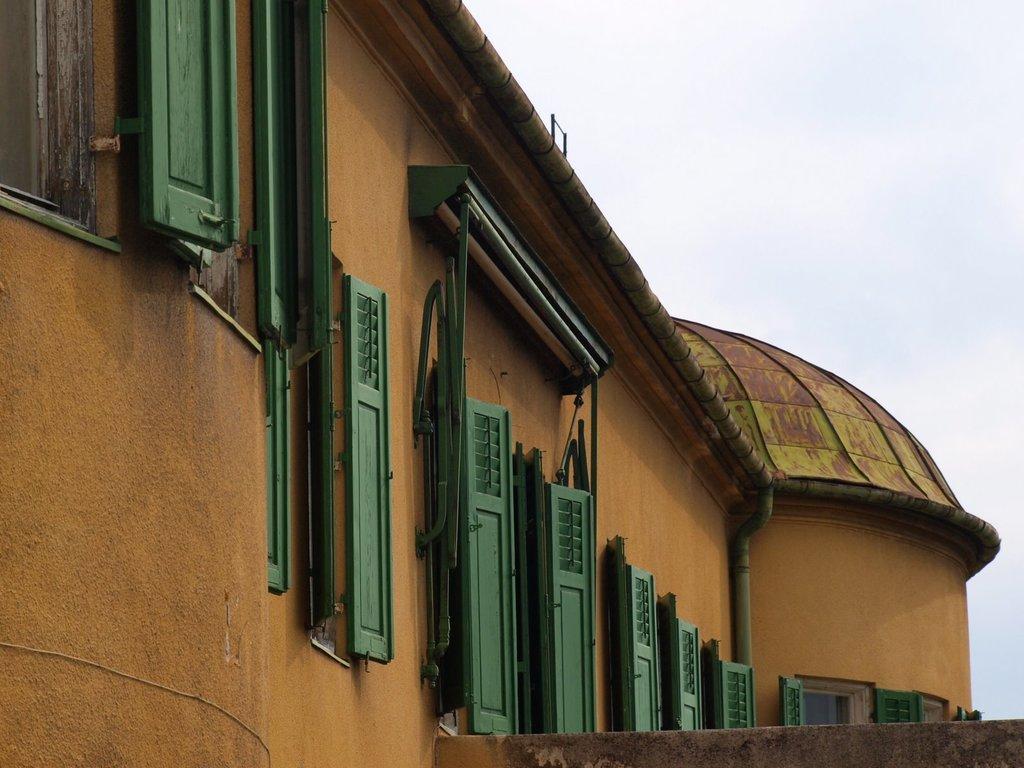How would you summarize this image in a sentence or two? In this picture we can see a house and few doors. 